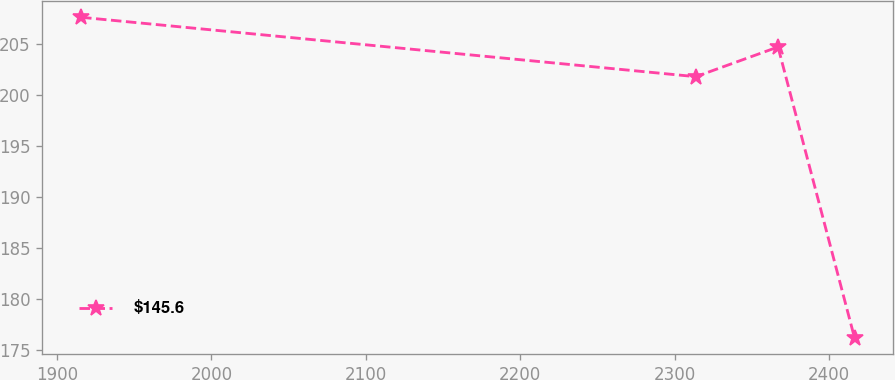Convert chart to OTSL. <chart><loc_0><loc_0><loc_500><loc_500><line_chart><ecel><fcel>$145.6<nl><fcel>1915.63<fcel>207.62<nl><fcel>2313.73<fcel>201.8<nl><fcel>2366.98<fcel>204.71<nl><fcel>2416.56<fcel>176.19<nl></chart> 